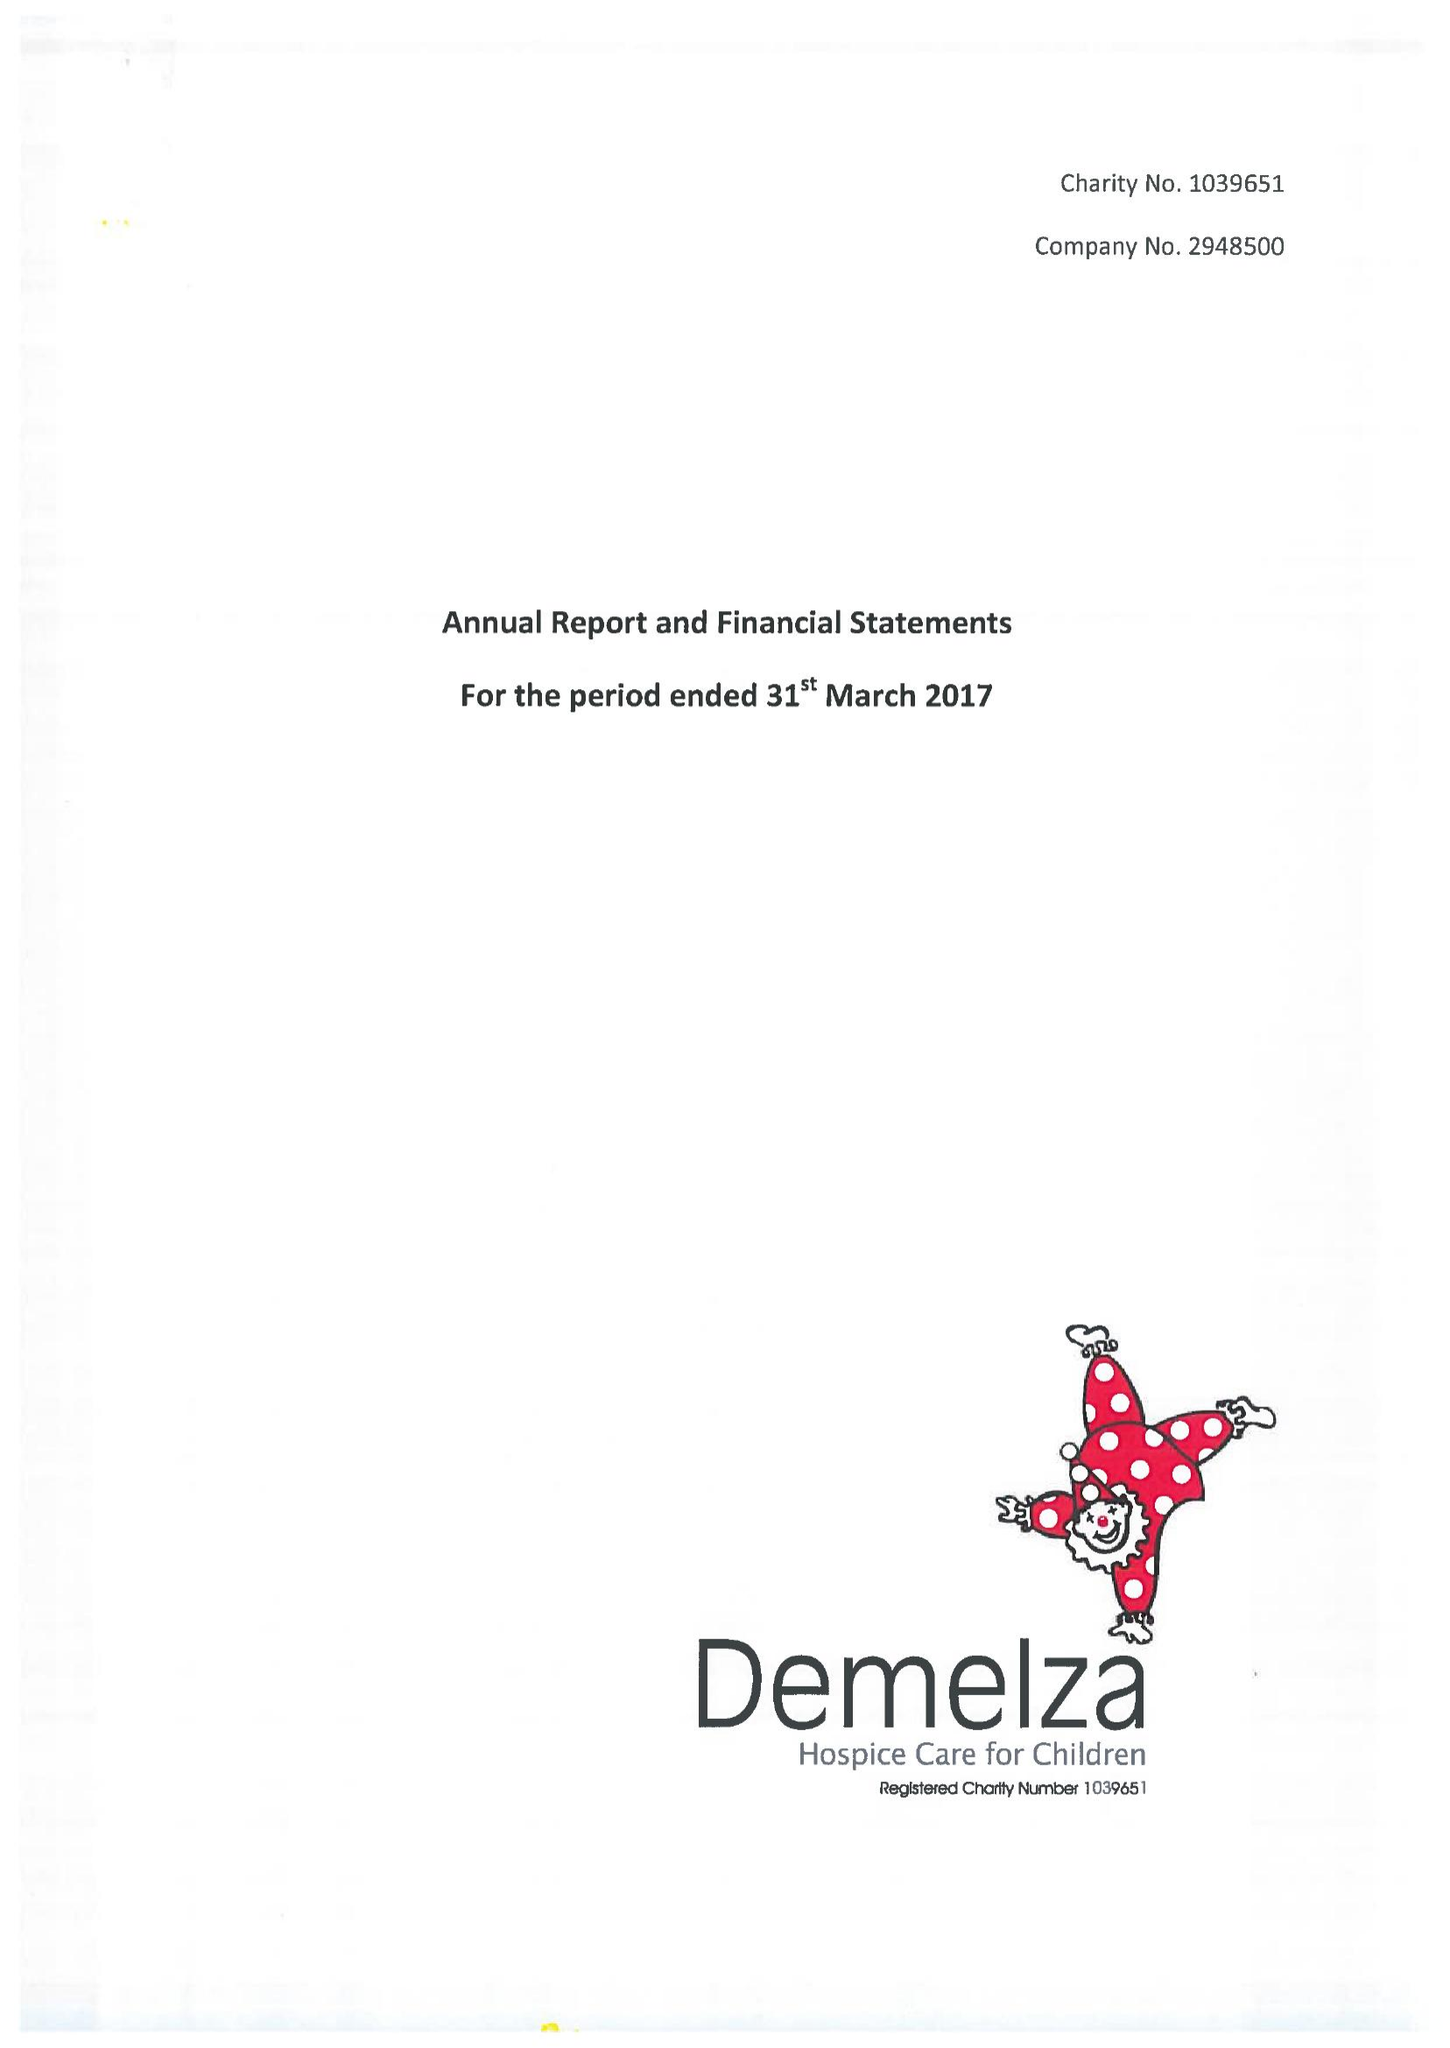What is the value for the address__postcode?
Answer the question using a single word or phrase. ME9 8DZ 